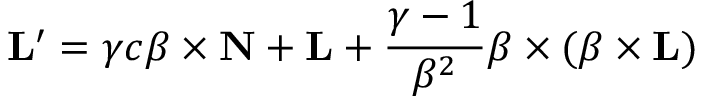Convert formula to latex. <formula><loc_0><loc_0><loc_500><loc_500>L ^ { \prime } = \gamma c { \beta } \times N + L + { \frac { \gamma - 1 } { \beta ^ { 2 } } } { \beta } \times ( { \beta } \times L )</formula> 